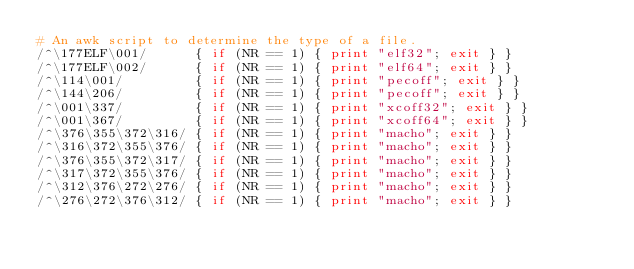Convert code to text. <code><loc_0><loc_0><loc_500><loc_500><_Awk_># An awk script to determine the type of a file.
/^\177ELF\001/      { if (NR == 1) { print "elf32"; exit } }
/^\177ELF\002/      { if (NR == 1) { print "elf64"; exit } }
/^\114\001/         { if (NR == 1) { print "pecoff"; exit } }
/^\144\206/         { if (NR == 1) { print "pecoff"; exit } }
/^\001\337/         { if (NR == 1) { print "xcoff32"; exit } }
/^\001\367/         { if (NR == 1) { print "xcoff64"; exit } }
/^\376\355\372\316/ { if (NR == 1) { print "macho"; exit } }
/^\316\372\355\376/ { if (NR == 1) { print "macho"; exit } }
/^\376\355\372\317/ { if (NR == 1) { print "macho"; exit } }
/^\317\372\355\376/ { if (NR == 1) { print "macho"; exit } }
/^\312\376\272\276/ { if (NR == 1) { print "macho"; exit } }
/^\276\272\376\312/ { if (NR == 1) { print "macho"; exit } }
</code> 